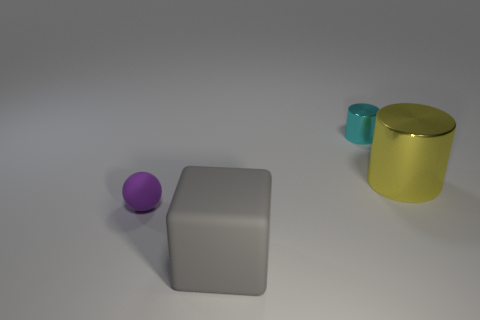Add 4 large cubes. How many objects exist? 8 Subtract all balls. How many objects are left? 3 Add 1 cyan metal cylinders. How many cyan metal cylinders exist? 2 Subtract 0 yellow spheres. How many objects are left? 4 Subtract all purple rubber things. Subtract all metal things. How many objects are left? 1 Add 1 yellow shiny cylinders. How many yellow shiny cylinders are left? 2 